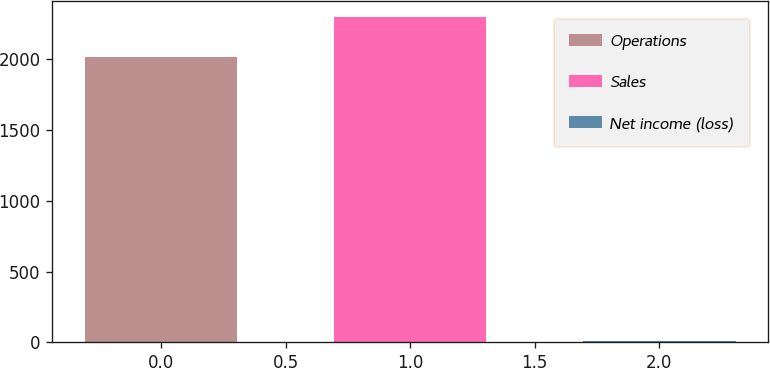Convert chart to OTSL. <chart><loc_0><loc_0><loc_500><loc_500><bar_chart><fcel>Operations<fcel>Sales<fcel>Net income (loss)<nl><fcel>2013<fcel>2299<fcel>10<nl></chart> 